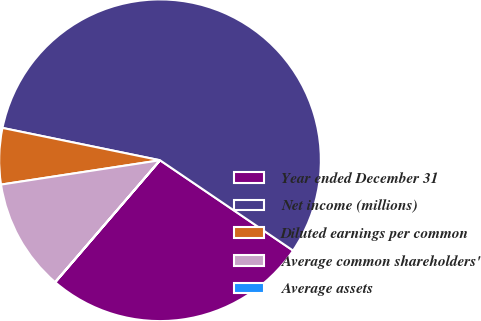Convert chart. <chart><loc_0><loc_0><loc_500><loc_500><pie_chart><fcel>Year ended December 31<fcel>Net income (millions)<fcel>Diluted earnings per common<fcel>Average common shareholders'<fcel>Average assets<nl><fcel>26.8%<fcel>56.27%<fcel>5.64%<fcel>11.27%<fcel>0.02%<nl></chart> 